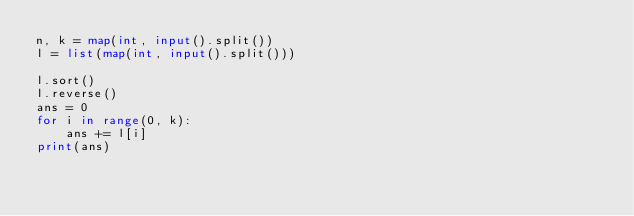Convert code to text. <code><loc_0><loc_0><loc_500><loc_500><_Python_>n, k = map(int, input().split())
l = list(map(int, input().split()))

l.sort()
l.reverse()
ans = 0
for i in range(0, k):
    ans += l[i]
print(ans)</code> 